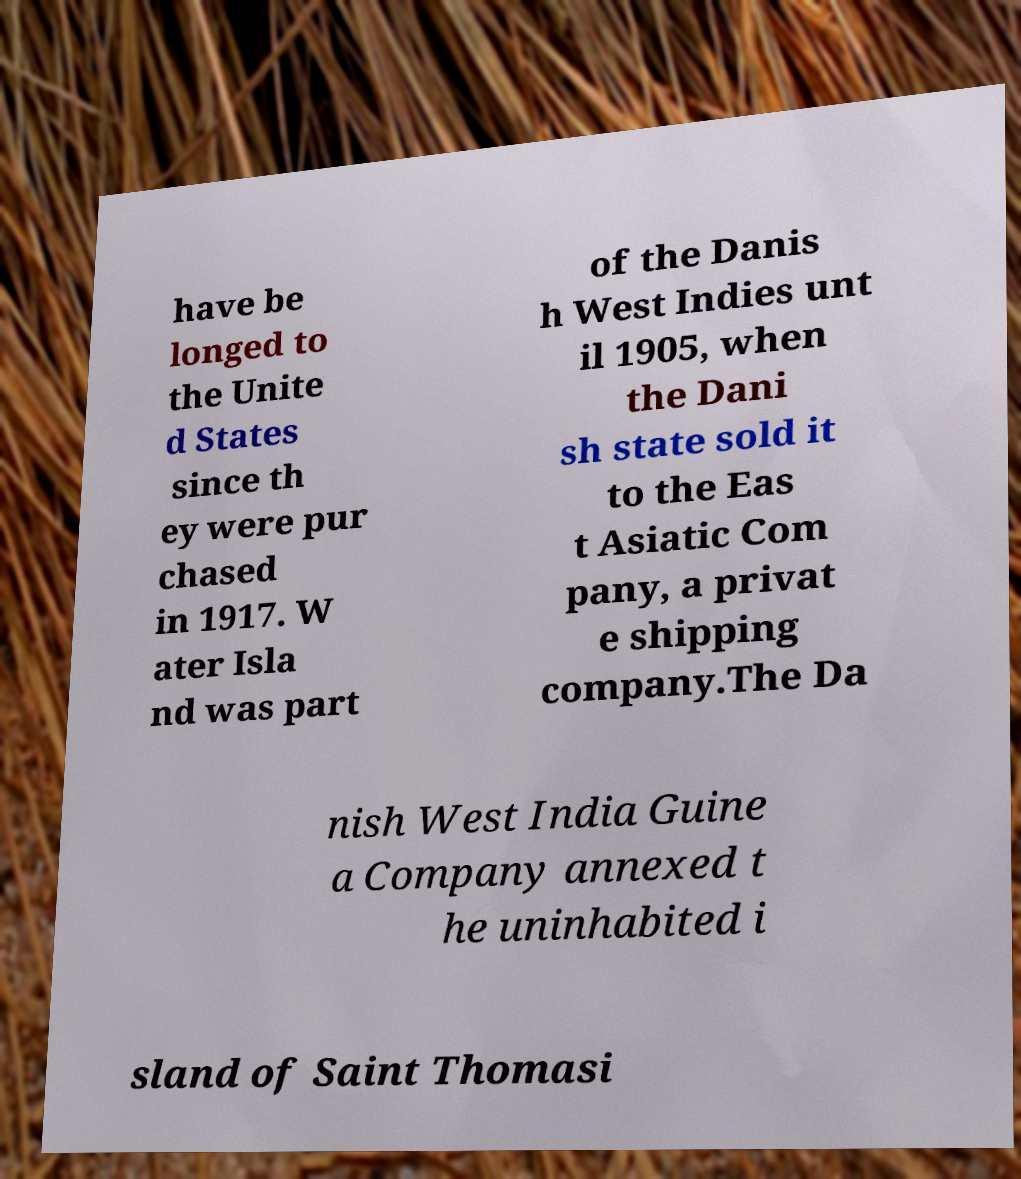Can you read and provide the text displayed in the image?This photo seems to have some interesting text. Can you extract and type it out for me? have be longed to the Unite d States since th ey were pur chased in 1917. W ater Isla nd was part of the Danis h West Indies unt il 1905, when the Dani sh state sold it to the Eas t Asiatic Com pany, a privat e shipping company.The Da nish West India Guine a Company annexed t he uninhabited i sland of Saint Thomasi 